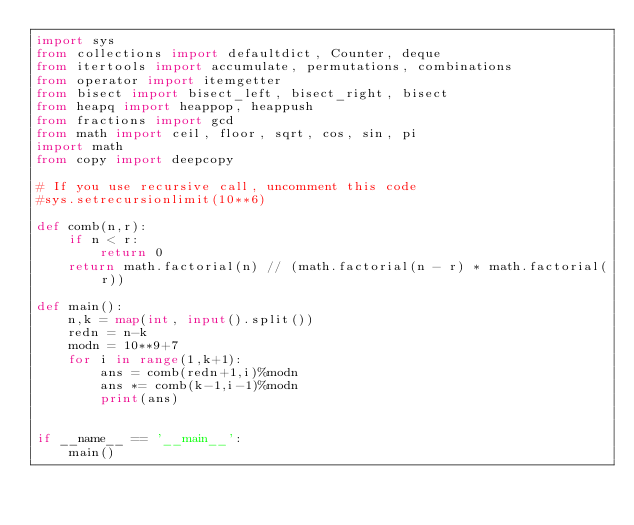<code> <loc_0><loc_0><loc_500><loc_500><_Python_>import sys
from collections import defaultdict, Counter, deque
from itertools import accumulate, permutations, combinations
from operator import itemgetter
from bisect import bisect_left, bisect_right, bisect
from heapq import heappop, heappush
from fractions import gcd
from math import ceil, floor, sqrt, cos, sin, pi
import math
from copy import deepcopy

# If you use recursive call, uncomment this code
#sys.setrecursionlimit(10**6)

def comb(n,r):
    if n < r:
        return 0
    return math.factorial(n) // (math.factorial(n - r) * math.factorial(r))

def main():
    n,k = map(int, input().split())
    redn = n-k
    modn = 10**9+7
    for i in range(1,k+1):
        ans = comb(redn+1,i)%modn
        ans *= comb(k-1,i-1)%modn
        print(ans)
        

if __name__ == '__main__':
    main()
</code> 